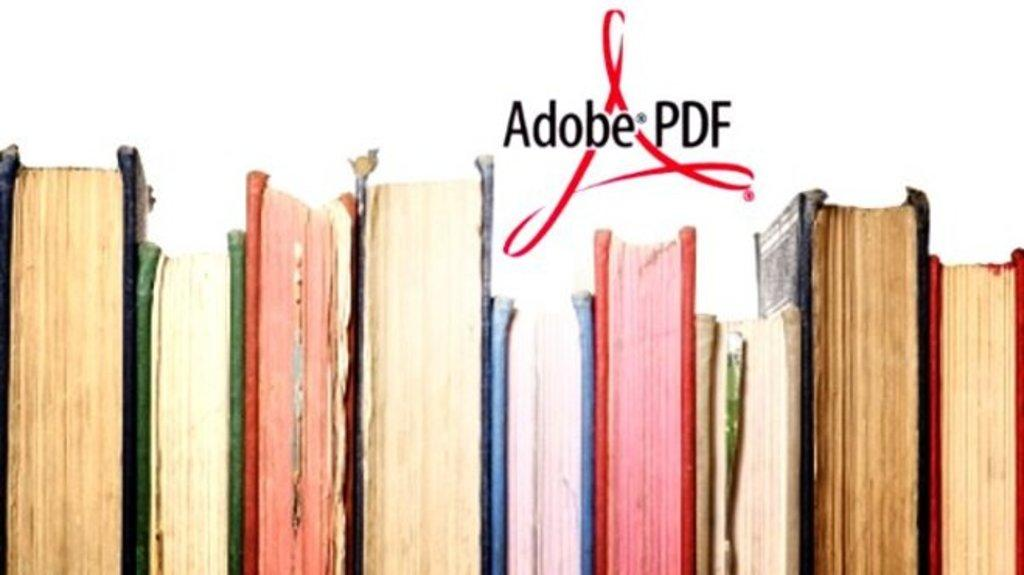<image>
Give a short and clear explanation of the subsequent image. The Adobe PDF logo is above a group of books. 